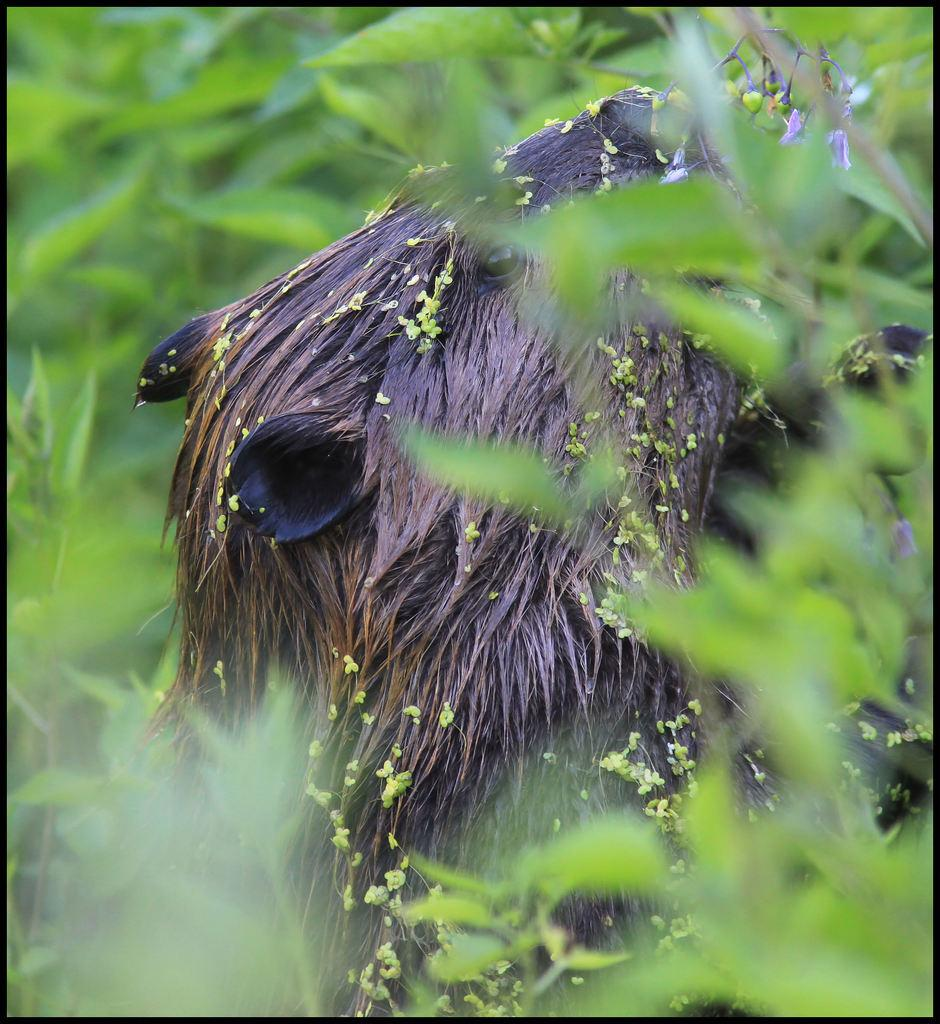What type of creature is present in the image? There is an animal in the image. What color is the animal? The animal is brown in color. What type of vegetation is visible in the image? There are green leaves in the image. Where is the fork placed in the image? There is no fork present in the image. What type of bedroom can be seen in the image? There is no bedroom present in the image. 